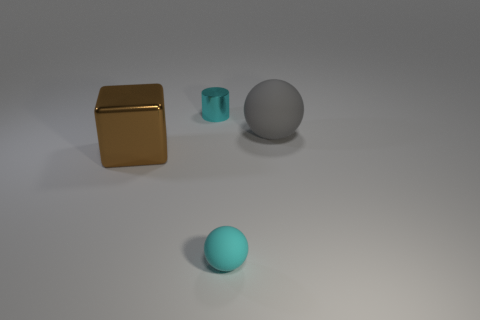What color is the big thing that is the same shape as the small matte thing?
Offer a terse response. Gray. What is the tiny cyan thing that is on the left side of the small object that is in front of the big shiny cube made of?
Offer a terse response. Metal. Does the matte object to the right of the small matte ball have the same shape as the tiny cyan thing that is in front of the big gray rubber ball?
Your answer should be compact. Yes. There is a thing that is on the left side of the gray rubber sphere and right of the tiny metallic cylinder; what is its size?
Provide a succinct answer. Small. What number of other objects are the same color as the small metal cylinder?
Make the answer very short. 1. Do the sphere behind the cyan rubber object and the large brown cube have the same material?
Make the answer very short. No. Is there any other thing that is the same size as the gray matte sphere?
Keep it short and to the point. Yes. Is the number of tiny cyan metallic cylinders that are on the right side of the gray rubber thing less than the number of small matte things that are in front of the large brown shiny cube?
Ensure brevity in your answer.  Yes. Are there any other things that have the same shape as the gray object?
Give a very brief answer. Yes. What material is the tiny cylinder that is the same color as the small rubber ball?
Keep it short and to the point. Metal. 